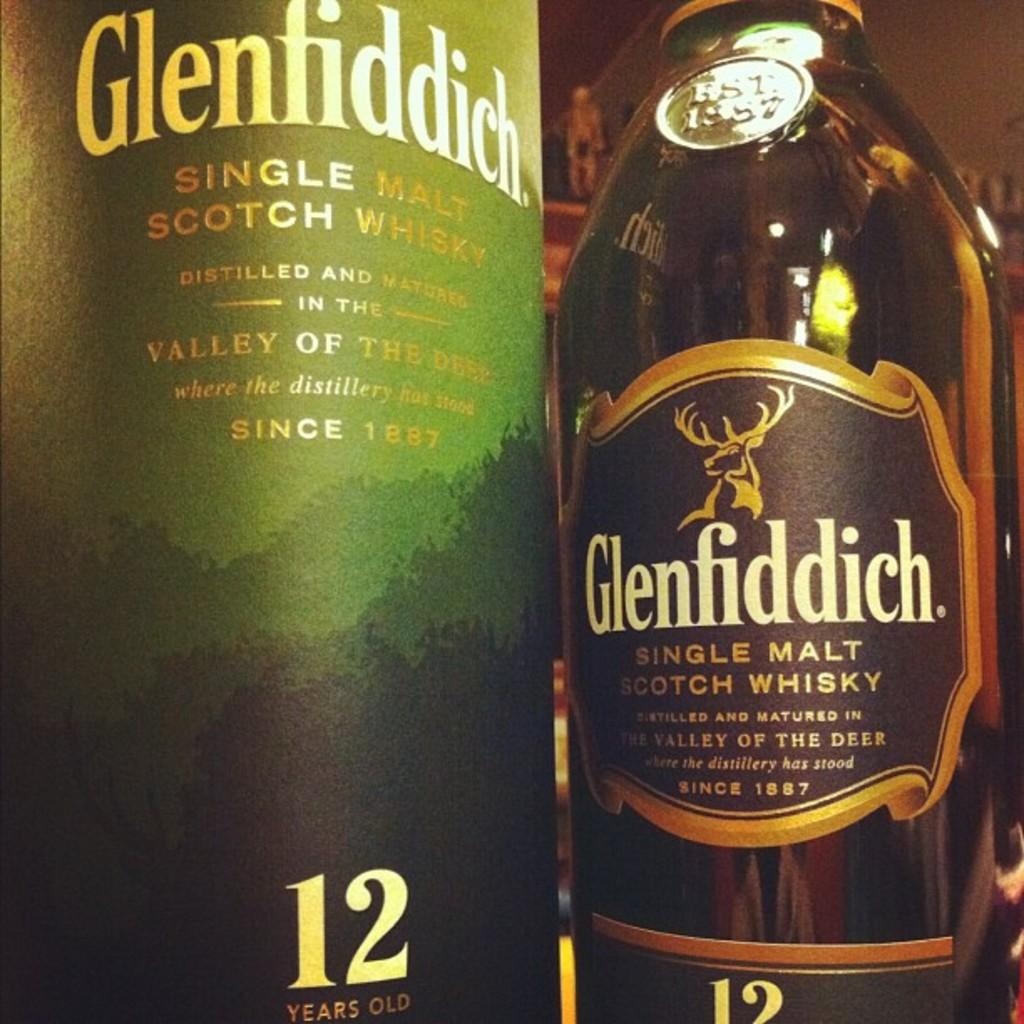<image>
Create a compact narrative representing the image presented. Bottle of alcohol with a moose and the word Glenfiddich on it. 